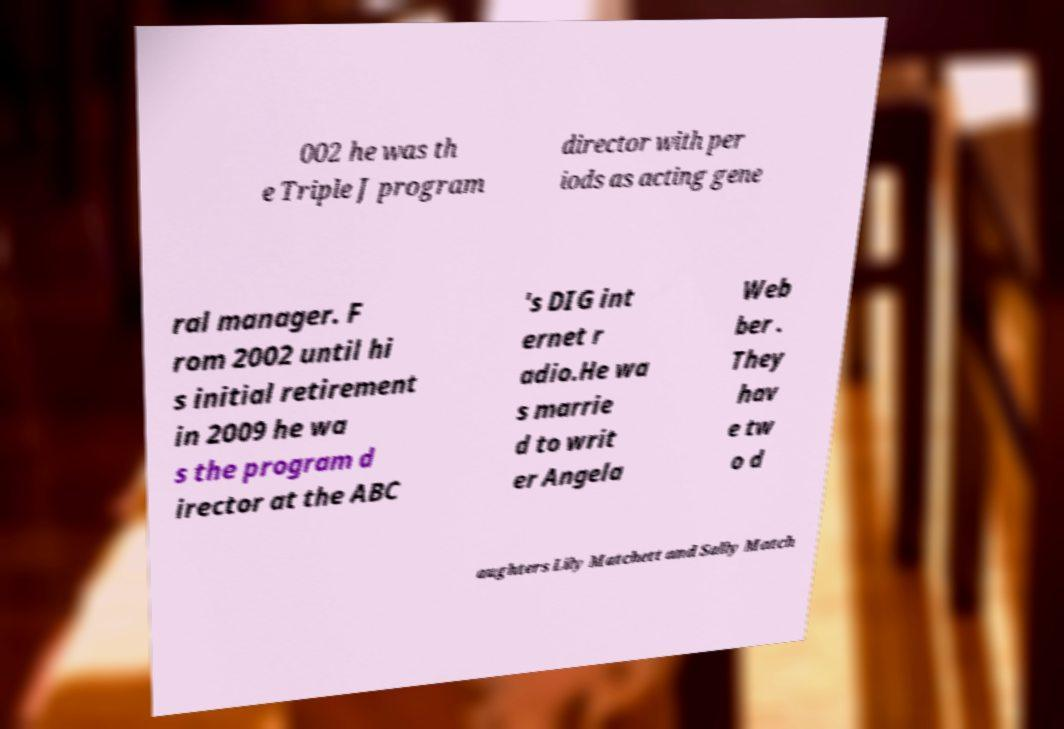I need the written content from this picture converted into text. Can you do that? 002 he was th e Triple J program director with per iods as acting gene ral manager. F rom 2002 until hi s initial retirement in 2009 he wa s the program d irector at the ABC 's DIG int ernet r adio.He wa s marrie d to writ er Angela Web ber . They hav e tw o d aughters Lily Matchett and Sally Match 